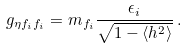<formula> <loc_0><loc_0><loc_500><loc_500>g _ { \eta f _ { i } f _ { i } } = m _ { f _ { i } } \frac { \epsilon _ { i } } { \sqrt { 1 - \langle h ^ { 2 } \rangle } } \, .</formula> 